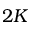Convert formula to latex. <formula><loc_0><loc_0><loc_500><loc_500>2 K</formula> 